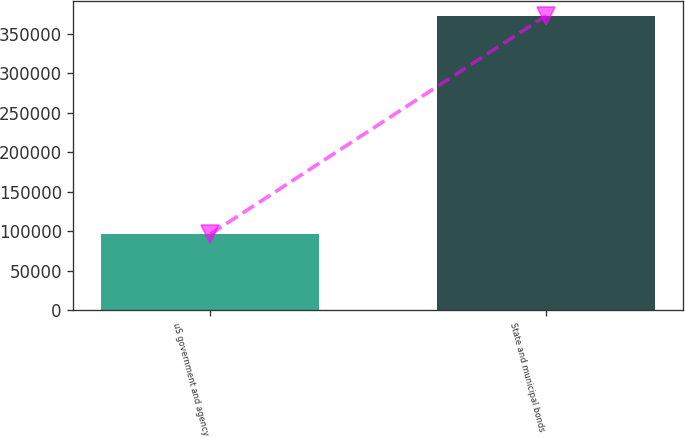<chart> <loc_0><loc_0><loc_500><loc_500><bar_chart><fcel>uS government and agency<fcel>State and municipal bonds<nl><fcel>96157<fcel>373169<nl></chart> 